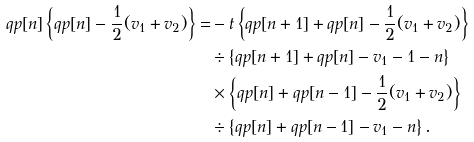Convert formula to latex. <formula><loc_0><loc_0><loc_500><loc_500>q p [ n ] \left \{ q p [ n ] - \frac { 1 } { 2 } ( v _ { 1 } + v _ { 2 } ) \right \} = & - t \left \{ q p [ n + 1 ] + q p [ n ] - \frac { 1 } { 2 } ( v _ { 1 } + v _ { 2 } ) \right \} \\ & \div \left \{ q p [ n + 1 ] + q p [ n ] - v _ { 1 } - 1 - n \right \} \\ & \times \left \{ q p [ n ] + q p [ n - 1 ] - \frac { 1 } { 2 } ( v _ { 1 } + v _ { 2 } ) \right \} \\ & \div \left \{ q p [ n ] + q p [ n - 1 ] - v _ { 1 } - n \right \} .</formula> 